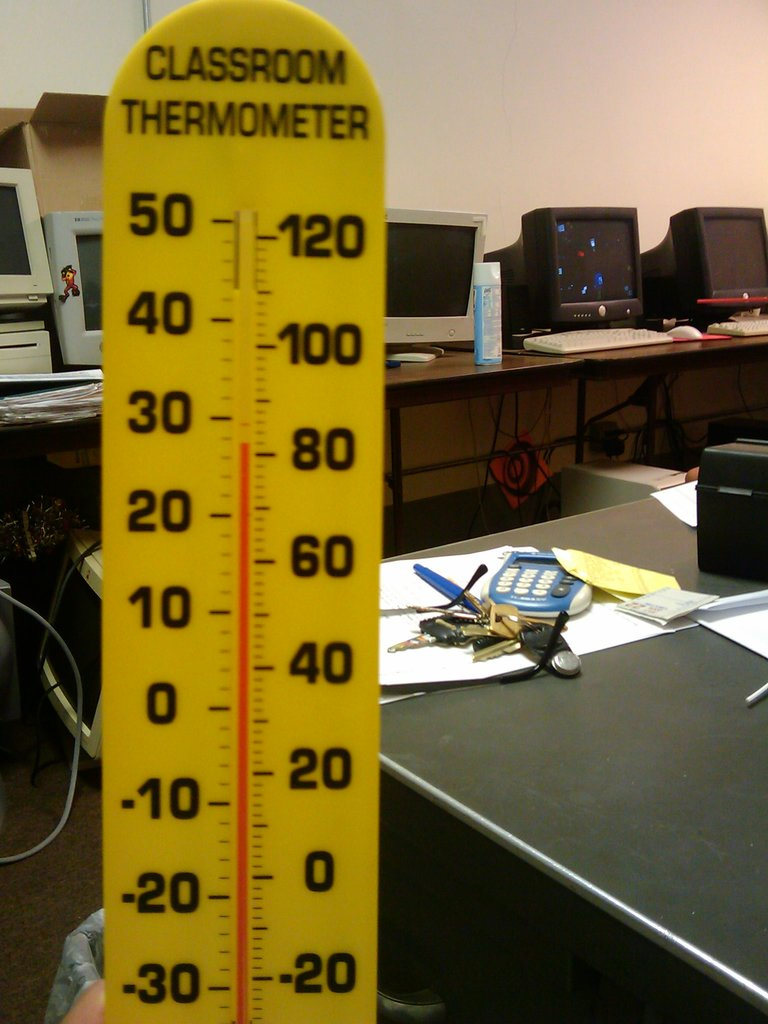Why might a classroom have such a large thermometer? A large, easily readable thermometer might be used in a classroom setting for educational purposes, such as teaching students about temperature and how to read thermometric scales. It's also a handy tool for demonstrating live temperature changes during experiments or during a weather-related curriculum. What could the collection of items on the desk tell us about the person working there? The assortment of objects, including keys, a calculator, and paperwork, suggests that the person who works at this desk likely fulfills multiple roles, possibly managing a facility or conducting tasks that require calculation and data entry. The presence of multiple keys hints at responsibilities for different areas or secure access needs. 